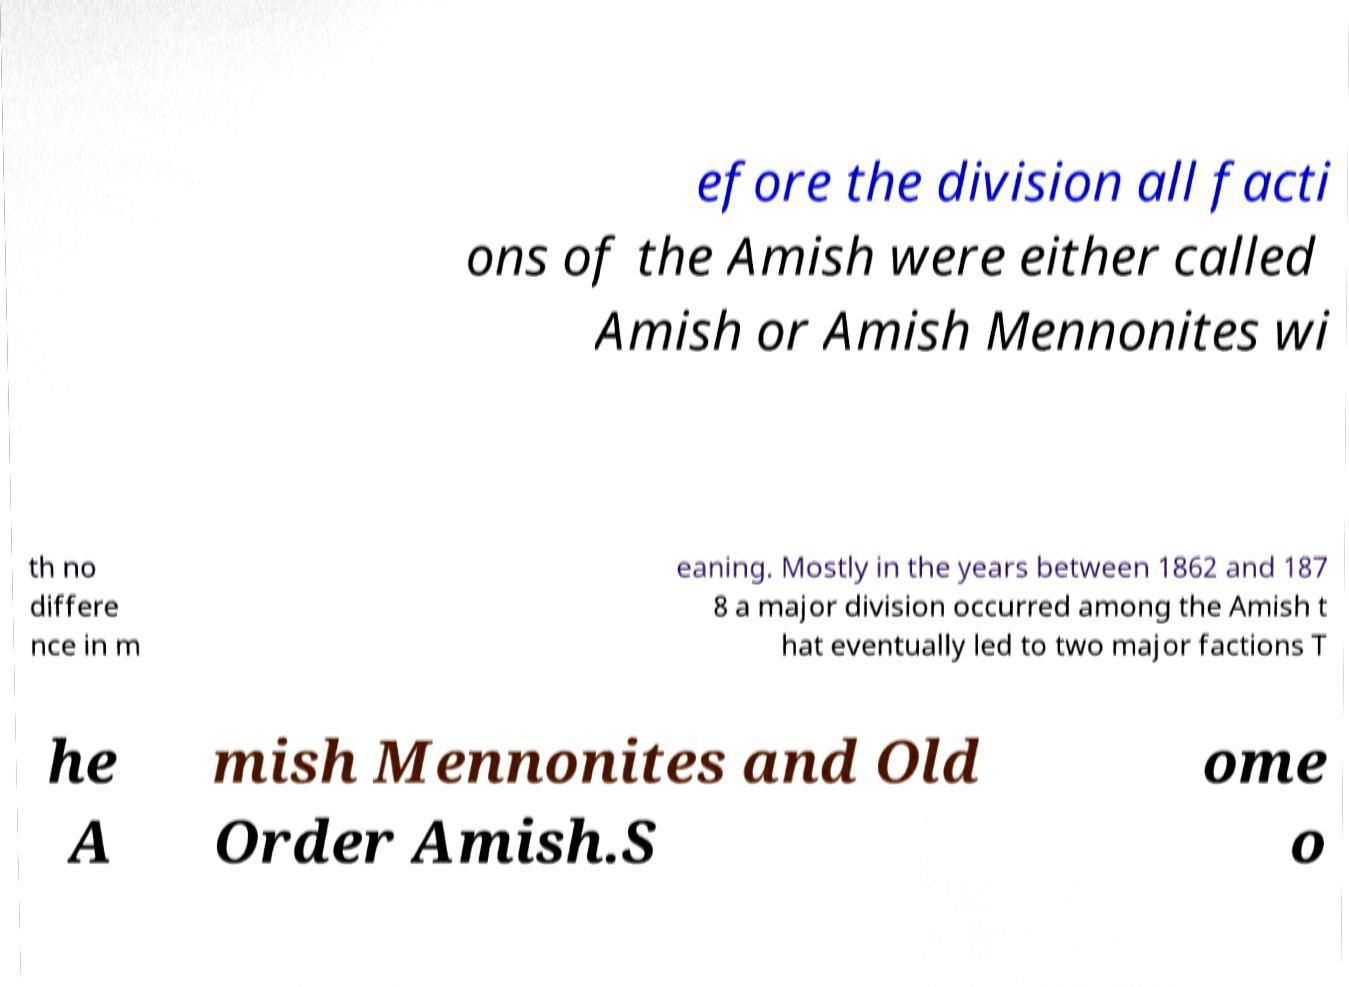Could you extract and type out the text from this image? efore the division all facti ons of the Amish were either called Amish or Amish Mennonites wi th no differe nce in m eaning. Mostly in the years between 1862 and 187 8 a major division occurred among the Amish t hat eventually led to two major factions T he A mish Mennonites and Old Order Amish.S ome o 